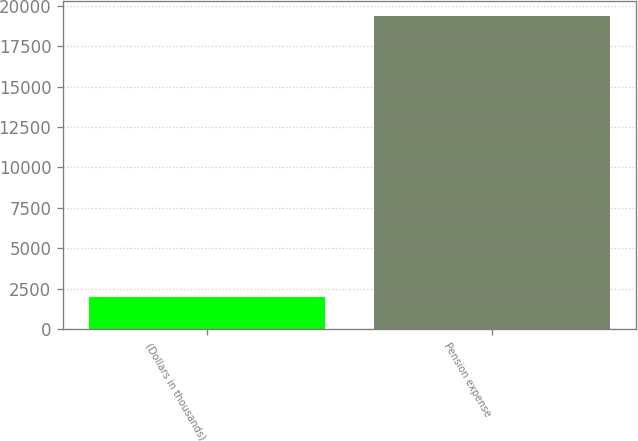Convert chart. <chart><loc_0><loc_0><loc_500><loc_500><bar_chart><fcel>(Dollars in thousands)<fcel>Pension expense<nl><fcel>2013<fcel>19348<nl></chart> 